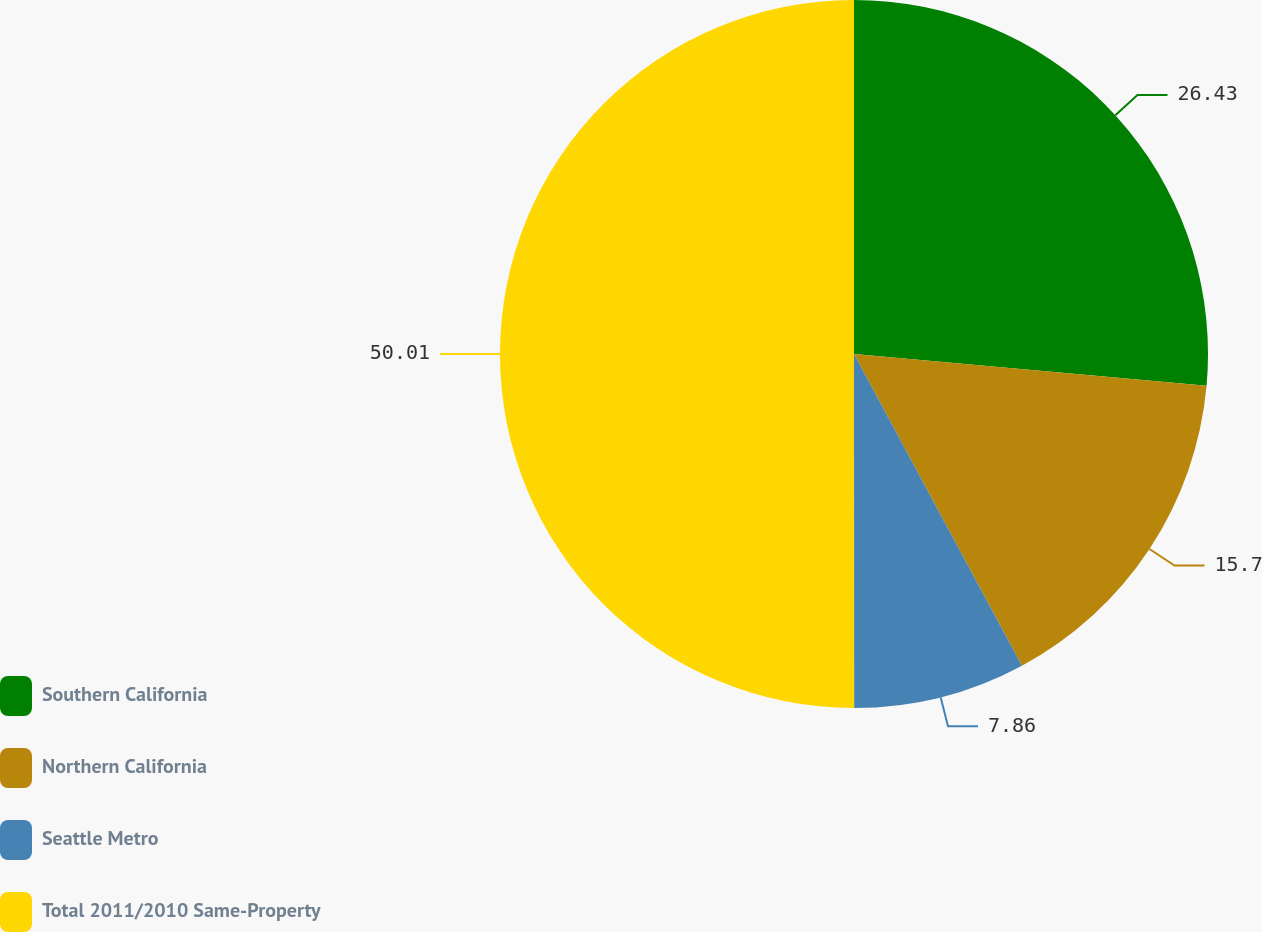Convert chart to OTSL. <chart><loc_0><loc_0><loc_500><loc_500><pie_chart><fcel>Southern California<fcel>Northern California<fcel>Seattle Metro<fcel>Total 2011/2010 Same-Property<nl><fcel>26.43%<fcel>15.7%<fcel>7.86%<fcel>50.0%<nl></chart> 